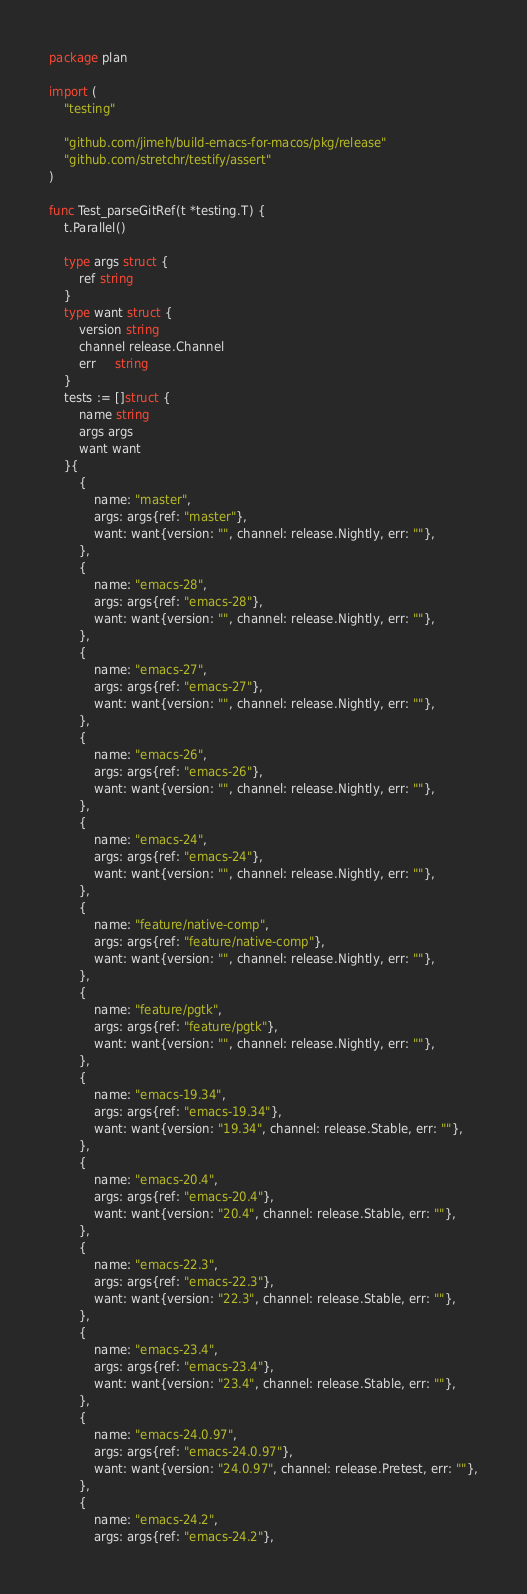Convert code to text. <code><loc_0><loc_0><loc_500><loc_500><_Go_>package plan

import (
	"testing"

	"github.com/jimeh/build-emacs-for-macos/pkg/release"
	"github.com/stretchr/testify/assert"
)

func Test_parseGitRef(t *testing.T) {
	t.Parallel()

	type args struct {
		ref string
	}
	type want struct {
		version string
		channel release.Channel
		err     string
	}
	tests := []struct {
		name string
		args args
		want want
	}{
		{
			name: "master",
			args: args{ref: "master"},
			want: want{version: "", channel: release.Nightly, err: ""},
		},
		{
			name: "emacs-28",
			args: args{ref: "emacs-28"},
			want: want{version: "", channel: release.Nightly, err: ""},
		},
		{
			name: "emacs-27",
			args: args{ref: "emacs-27"},
			want: want{version: "", channel: release.Nightly, err: ""},
		},
		{
			name: "emacs-26",
			args: args{ref: "emacs-26"},
			want: want{version: "", channel: release.Nightly, err: ""},
		},
		{
			name: "emacs-24",
			args: args{ref: "emacs-24"},
			want: want{version: "", channel: release.Nightly, err: ""},
		},
		{
			name: "feature/native-comp",
			args: args{ref: "feature/native-comp"},
			want: want{version: "", channel: release.Nightly, err: ""},
		},
		{
			name: "feature/pgtk",
			args: args{ref: "feature/pgtk"},
			want: want{version: "", channel: release.Nightly, err: ""},
		},
		{
			name: "emacs-19.34",
			args: args{ref: "emacs-19.34"},
			want: want{version: "19.34", channel: release.Stable, err: ""},
		},
		{
			name: "emacs-20.4",
			args: args{ref: "emacs-20.4"},
			want: want{version: "20.4", channel: release.Stable, err: ""},
		},
		{
			name: "emacs-22.3",
			args: args{ref: "emacs-22.3"},
			want: want{version: "22.3", channel: release.Stable, err: ""},
		},
		{
			name: "emacs-23.4",
			args: args{ref: "emacs-23.4"},
			want: want{version: "23.4", channel: release.Stable, err: ""},
		},
		{
			name: "emacs-24.0.97",
			args: args{ref: "emacs-24.0.97"},
			want: want{version: "24.0.97", channel: release.Pretest, err: ""},
		},
		{
			name: "emacs-24.2",
			args: args{ref: "emacs-24.2"},</code> 